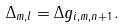<formula> <loc_0><loc_0><loc_500><loc_500>\Delta _ { m , l } = \Delta g _ { i , m , n + 1 } .</formula> 